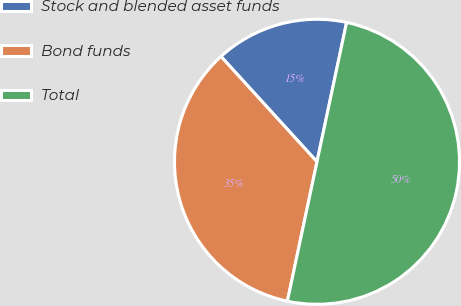Convert chart to OTSL. <chart><loc_0><loc_0><loc_500><loc_500><pie_chart><fcel>Stock and blended asset funds<fcel>Bond funds<fcel>Total<nl><fcel>15.1%<fcel>34.9%<fcel>50.0%<nl></chart> 